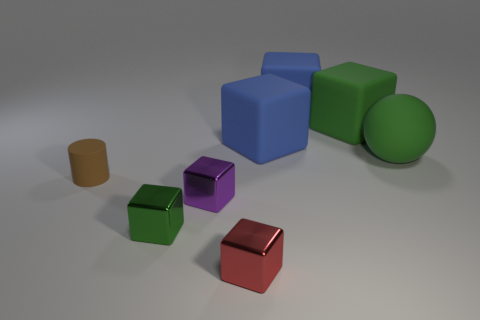Subtract all small red blocks. How many blocks are left? 5 Subtract all blue cubes. How many cubes are left? 4 Add 1 green rubber balls. How many objects exist? 9 Subtract all cylinders. How many objects are left? 7 Subtract all green blocks. Subtract all purple spheres. How many blocks are left? 4 Subtract all cylinders. Subtract all small red metallic cubes. How many objects are left? 6 Add 3 cylinders. How many cylinders are left? 4 Add 8 small brown things. How many small brown things exist? 9 Subtract 0 brown blocks. How many objects are left? 8 